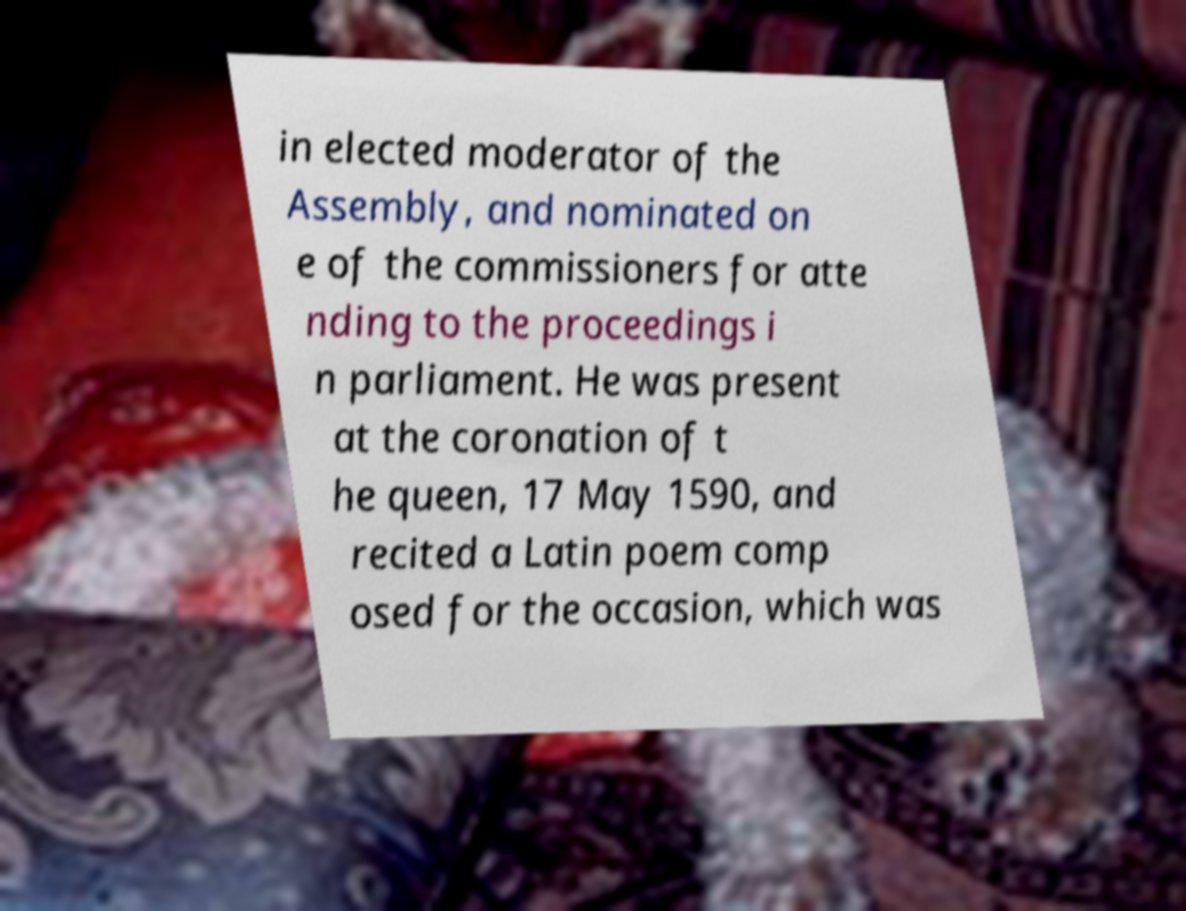Please read and relay the text visible in this image. What does it say? in elected moderator of the Assembly, and nominated on e of the commissioners for atte nding to the proceedings i n parliament. He was present at the coronation of t he queen, 17 May 1590, and recited a Latin poem comp osed for the occasion, which was 